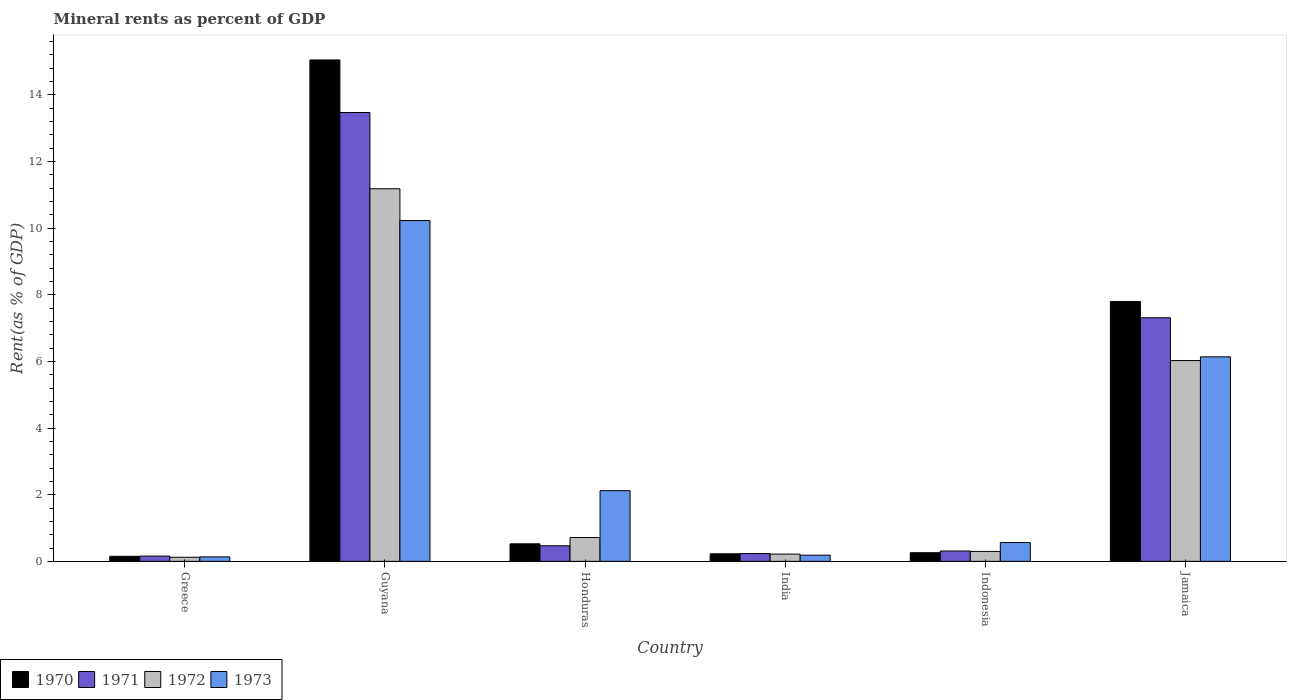How many different coloured bars are there?
Give a very brief answer. 4. How many groups of bars are there?
Keep it short and to the point. 6. How many bars are there on the 4th tick from the right?
Keep it short and to the point. 4. In how many cases, is the number of bars for a given country not equal to the number of legend labels?
Offer a very short reply. 0. What is the mineral rent in 1970 in Greece?
Provide a short and direct response. 0.15. Across all countries, what is the maximum mineral rent in 1972?
Your response must be concise. 11.18. Across all countries, what is the minimum mineral rent in 1972?
Your answer should be compact. 0.12. In which country was the mineral rent in 1971 maximum?
Offer a very short reply. Guyana. In which country was the mineral rent in 1971 minimum?
Give a very brief answer. Greece. What is the total mineral rent in 1972 in the graph?
Ensure brevity in your answer.  18.56. What is the difference between the mineral rent in 1972 in Greece and that in India?
Ensure brevity in your answer.  -0.09. What is the difference between the mineral rent in 1971 in Honduras and the mineral rent in 1970 in Indonesia?
Your response must be concise. 0.21. What is the average mineral rent in 1972 per country?
Give a very brief answer. 3.09. What is the difference between the mineral rent of/in 1973 and mineral rent of/in 1972 in Guyana?
Keep it short and to the point. -0.95. What is the ratio of the mineral rent in 1971 in Greece to that in Guyana?
Your response must be concise. 0.01. Is the mineral rent in 1970 in Greece less than that in India?
Provide a short and direct response. Yes. What is the difference between the highest and the second highest mineral rent in 1972?
Ensure brevity in your answer.  -10.47. What is the difference between the highest and the lowest mineral rent in 1973?
Your answer should be compact. 10.09. In how many countries, is the mineral rent in 1971 greater than the average mineral rent in 1971 taken over all countries?
Offer a very short reply. 2. Is it the case that in every country, the sum of the mineral rent in 1970 and mineral rent in 1973 is greater than the sum of mineral rent in 1972 and mineral rent in 1971?
Ensure brevity in your answer.  No. What does the 3rd bar from the right in India represents?
Keep it short and to the point. 1971. How many bars are there?
Offer a terse response. 24. Are all the bars in the graph horizontal?
Make the answer very short. No. Where does the legend appear in the graph?
Offer a terse response. Bottom left. How many legend labels are there?
Provide a short and direct response. 4. How are the legend labels stacked?
Offer a terse response. Horizontal. What is the title of the graph?
Ensure brevity in your answer.  Mineral rents as percent of GDP. Does "1969" appear as one of the legend labels in the graph?
Give a very brief answer. No. What is the label or title of the Y-axis?
Offer a terse response. Rent(as % of GDP). What is the Rent(as % of GDP) in 1970 in Greece?
Give a very brief answer. 0.15. What is the Rent(as % of GDP) in 1971 in Greece?
Provide a short and direct response. 0.16. What is the Rent(as % of GDP) in 1972 in Greece?
Your response must be concise. 0.12. What is the Rent(as % of GDP) in 1973 in Greece?
Offer a very short reply. 0.13. What is the Rent(as % of GDP) of 1970 in Guyana?
Provide a succinct answer. 15.05. What is the Rent(as % of GDP) in 1971 in Guyana?
Ensure brevity in your answer.  13.47. What is the Rent(as % of GDP) of 1972 in Guyana?
Make the answer very short. 11.18. What is the Rent(as % of GDP) of 1973 in Guyana?
Keep it short and to the point. 10.23. What is the Rent(as % of GDP) in 1970 in Honduras?
Give a very brief answer. 0.53. What is the Rent(as % of GDP) of 1971 in Honduras?
Your answer should be very brief. 0.47. What is the Rent(as % of GDP) of 1972 in Honduras?
Provide a succinct answer. 0.72. What is the Rent(as % of GDP) in 1973 in Honduras?
Keep it short and to the point. 2.12. What is the Rent(as % of GDP) of 1970 in India?
Ensure brevity in your answer.  0.23. What is the Rent(as % of GDP) of 1971 in India?
Your answer should be compact. 0.23. What is the Rent(as % of GDP) in 1972 in India?
Offer a very short reply. 0.22. What is the Rent(as % of GDP) of 1973 in India?
Provide a short and direct response. 0.19. What is the Rent(as % of GDP) in 1970 in Indonesia?
Provide a succinct answer. 0.26. What is the Rent(as % of GDP) in 1971 in Indonesia?
Make the answer very short. 0.31. What is the Rent(as % of GDP) in 1972 in Indonesia?
Provide a succinct answer. 0.3. What is the Rent(as % of GDP) of 1973 in Indonesia?
Provide a short and direct response. 0.56. What is the Rent(as % of GDP) in 1970 in Jamaica?
Provide a short and direct response. 7.8. What is the Rent(as % of GDP) in 1971 in Jamaica?
Your answer should be compact. 7.31. What is the Rent(as % of GDP) in 1972 in Jamaica?
Provide a succinct answer. 6.03. What is the Rent(as % of GDP) in 1973 in Jamaica?
Keep it short and to the point. 6.14. Across all countries, what is the maximum Rent(as % of GDP) in 1970?
Keep it short and to the point. 15.05. Across all countries, what is the maximum Rent(as % of GDP) in 1971?
Provide a short and direct response. 13.47. Across all countries, what is the maximum Rent(as % of GDP) of 1972?
Give a very brief answer. 11.18. Across all countries, what is the maximum Rent(as % of GDP) of 1973?
Provide a succinct answer. 10.23. Across all countries, what is the minimum Rent(as % of GDP) of 1970?
Provide a succinct answer. 0.15. Across all countries, what is the minimum Rent(as % of GDP) in 1971?
Keep it short and to the point. 0.16. Across all countries, what is the minimum Rent(as % of GDP) of 1972?
Your response must be concise. 0.12. Across all countries, what is the minimum Rent(as % of GDP) in 1973?
Keep it short and to the point. 0.13. What is the total Rent(as % of GDP) in 1970 in the graph?
Your response must be concise. 24.01. What is the total Rent(as % of GDP) of 1971 in the graph?
Your response must be concise. 21.95. What is the total Rent(as % of GDP) in 1972 in the graph?
Your response must be concise. 18.56. What is the total Rent(as % of GDP) in 1973 in the graph?
Make the answer very short. 19.37. What is the difference between the Rent(as % of GDP) of 1970 in Greece and that in Guyana?
Your response must be concise. -14.9. What is the difference between the Rent(as % of GDP) of 1971 in Greece and that in Guyana?
Your answer should be compact. -13.31. What is the difference between the Rent(as % of GDP) of 1972 in Greece and that in Guyana?
Offer a very short reply. -11.06. What is the difference between the Rent(as % of GDP) in 1973 in Greece and that in Guyana?
Provide a succinct answer. -10.09. What is the difference between the Rent(as % of GDP) in 1970 in Greece and that in Honduras?
Your answer should be very brief. -0.37. What is the difference between the Rent(as % of GDP) of 1971 in Greece and that in Honduras?
Give a very brief answer. -0.31. What is the difference between the Rent(as % of GDP) of 1972 in Greece and that in Honduras?
Your answer should be compact. -0.59. What is the difference between the Rent(as % of GDP) in 1973 in Greece and that in Honduras?
Offer a very short reply. -1.99. What is the difference between the Rent(as % of GDP) in 1970 in Greece and that in India?
Offer a very short reply. -0.07. What is the difference between the Rent(as % of GDP) of 1971 in Greece and that in India?
Offer a very short reply. -0.08. What is the difference between the Rent(as % of GDP) of 1972 in Greece and that in India?
Your response must be concise. -0.09. What is the difference between the Rent(as % of GDP) of 1973 in Greece and that in India?
Your answer should be very brief. -0.05. What is the difference between the Rent(as % of GDP) of 1970 in Greece and that in Indonesia?
Ensure brevity in your answer.  -0.11. What is the difference between the Rent(as % of GDP) of 1971 in Greece and that in Indonesia?
Keep it short and to the point. -0.15. What is the difference between the Rent(as % of GDP) in 1972 in Greece and that in Indonesia?
Your answer should be compact. -0.18. What is the difference between the Rent(as % of GDP) in 1973 in Greece and that in Indonesia?
Ensure brevity in your answer.  -0.43. What is the difference between the Rent(as % of GDP) in 1970 in Greece and that in Jamaica?
Make the answer very short. -7.65. What is the difference between the Rent(as % of GDP) of 1971 in Greece and that in Jamaica?
Your response must be concise. -7.15. What is the difference between the Rent(as % of GDP) in 1972 in Greece and that in Jamaica?
Your answer should be compact. -5.9. What is the difference between the Rent(as % of GDP) in 1973 in Greece and that in Jamaica?
Your response must be concise. -6. What is the difference between the Rent(as % of GDP) of 1970 in Guyana and that in Honduras?
Offer a very short reply. 14.52. What is the difference between the Rent(as % of GDP) in 1971 in Guyana and that in Honduras?
Your response must be concise. 13. What is the difference between the Rent(as % of GDP) of 1972 in Guyana and that in Honduras?
Offer a very short reply. 10.47. What is the difference between the Rent(as % of GDP) in 1973 in Guyana and that in Honduras?
Give a very brief answer. 8.11. What is the difference between the Rent(as % of GDP) of 1970 in Guyana and that in India?
Your response must be concise. 14.82. What is the difference between the Rent(as % of GDP) in 1971 in Guyana and that in India?
Offer a very short reply. 13.24. What is the difference between the Rent(as % of GDP) in 1972 in Guyana and that in India?
Give a very brief answer. 10.96. What is the difference between the Rent(as % of GDP) in 1973 in Guyana and that in India?
Offer a very short reply. 10.04. What is the difference between the Rent(as % of GDP) of 1970 in Guyana and that in Indonesia?
Ensure brevity in your answer.  14.79. What is the difference between the Rent(as % of GDP) in 1971 in Guyana and that in Indonesia?
Ensure brevity in your answer.  13.16. What is the difference between the Rent(as % of GDP) in 1972 in Guyana and that in Indonesia?
Your answer should be very brief. 10.88. What is the difference between the Rent(as % of GDP) in 1973 in Guyana and that in Indonesia?
Make the answer very short. 9.66. What is the difference between the Rent(as % of GDP) of 1970 in Guyana and that in Jamaica?
Your response must be concise. 7.25. What is the difference between the Rent(as % of GDP) of 1971 in Guyana and that in Jamaica?
Your answer should be very brief. 6.16. What is the difference between the Rent(as % of GDP) of 1972 in Guyana and that in Jamaica?
Your response must be concise. 5.16. What is the difference between the Rent(as % of GDP) of 1973 in Guyana and that in Jamaica?
Your answer should be compact. 4.09. What is the difference between the Rent(as % of GDP) of 1970 in Honduras and that in India?
Provide a succinct answer. 0.3. What is the difference between the Rent(as % of GDP) of 1971 in Honduras and that in India?
Ensure brevity in your answer.  0.23. What is the difference between the Rent(as % of GDP) of 1972 in Honduras and that in India?
Your response must be concise. 0.5. What is the difference between the Rent(as % of GDP) of 1973 in Honduras and that in India?
Provide a succinct answer. 1.94. What is the difference between the Rent(as % of GDP) in 1970 in Honduras and that in Indonesia?
Provide a short and direct response. 0.27. What is the difference between the Rent(as % of GDP) in 1971 in Honduras and that in Indonesia?
Provide a short and direct response. 0.16. What is the difference between the Rent(as % of GDP) of 1972 in Honduras and that in Indonesia?
Your response must be concise. 0.42. What is the difference between the Rent(as % of GDP) in 1973 in Honduras and that in Indonesia?
Keep it short and to the point. 1.56. What is the difference between the Rent(as % of GDP) of 1970 in Honduras and that in Jamaica?
Ensure brevity in your answer.  -7.27. What is the difference between the Rent(as % of GDP) of 1971 in Honduras and that in Jamaica?
Make the answer very short. -6.84. What is the difference between the Rent(as % of GDP) of 1972 in Honduras and that in Jamaica?
Your answer should be very brief. -5.31. What is the difference between the Rent(as % of GDP) in 1973 in Honduras and that in Jamaica?
Your answer should be very brief. -4.02. What is the difference between the Rent(as % of GDP) of 1970 in India and that in Indonesia?
Provide a short and direct response. -0.03. What is the difference between the Rent(as % of GDP) in 1971 in India and that in Indonesia?
Your answer should be compact. -0.08. What is the difference between the Rent(as % of GDP) in 1972 in India and that in Indonesia?
Your response must be concise. -0.08. What is the difference between the Rent(as % of GDP) of 1973 in India and that in Indonesia?
Offer a terse response. -0.38. What is the difference between the Rent(as % of GDP) of 1970 in India and that in Jamaica?
Keep it short and to the point. -7.57. What is the difference between the Rent(as % of GDP) of 1971 in India and that in Jamaica?
Your answer should be very brief. -7.08. What is the difference between the Rent(as % of GDP) in 1972 in India and that in Jamaica?
Provide a succinct answer. -5.81. What is the difference between the Rent(as % of GDP) of 1973 in India and that in Jamaica?
Your answer should be very brief. -5.95. What is the difference between the Rent(as % of GDP) of 1970 in Indonesia and that in Jamaica?
Keep it short and to the point. -7.54. What is the difference between the Rent(as % of GDP) of 1971 in Indonesia and that in Jamaica?
Your response must be concise. -7. What is the difference between the Rent(as % of GDP) of 1972 in Indonesia and that in Jamaica?
Provide a succinct answer. -5.73. What is the difference between the Rent(as % of GDP) in 1973 in Indonesia and that in Jamaica?
Ensure brevity in your answer.  -5.57. What is the difference between the Rent(as % of GDP) in 1970 in Greece and the Rent(as % of GDP) in 1971 in Guyana?
Give a very brief answer. -13.32. What is the difference between the Rent(as % of GDP) of 1970 in Greece and the Rent(as % of GDP) of 1972 in Guyana?
Provide a succinct answer. -11.03. What is the difference between the Rent(as % of GDP) of 1970 in Greece and the Rent(as % of GDP) of 1973 in Guyana?
Ensure brevity in your answer.  -10.08. What is the difference between the Rent(as % of GDP) in 1971 in Greece and the Rent(as % of GDP) in 1972 in Guyana?
Make the answer very short. -11.02. What is the difference between the Rent(as % of GDP) of 1971 in Greece and the Rent(as % of GDP) of 1973 in Guyana?
Your response must be concise. -10.07. What is the difference between the Rent(as % of GDP) in 1972 in Greece and the Rent(as % of GDP) in 1973 in Guyana?
Offer a terse response. -10.1. What is the difference between the Rent(as % of GDP) of 1970 in Greece and the Rent(as % of GDP) of 1971 in Honduras?
Your response must be concise. -0.32. What is the difference between the Rent(as % of GDP) of 1970 in Greece and the Rent(as % of GDP) of 1972 in Honduras?
Your answer should be very brief. -0.56. What is the difference between the Rent(as % of GDP) in 1970 in Greece and the Rent(as % of GDP) in 1973 in Honduras?
Offer a very short reply. -1.97. What is the difference between the Rent(as % of GDP) in 1971 in Greece and the Rent(as % of GDP) in 1972 in Honduras?
Offer a very short reply. -0.56. What is the difference between the Rent(as % of GDP) in 1971 in Greece and the Rent(as % of GDP) in 1973 in Honduras?
Provide a succinct answer. -1.96. What is the difference between the Rent(as % of GDP) in 1972 in Greece and the Rent(as % of GDP) in 1973 in Honduras?
Your response must be concise. -2. What is the difference between the Rent(as % of GDP) of 1970 in Greece and the Rent(as % of GDP) of 1971 in India?
Your response must be concise. -0.08. What is the difference between the Rent(as % of GDP) in 1970 in Greece and the Rent(as % of GDP) in 1972 in India?
Keep it short and to the point. -0.07. What is the difference between the Rent(as % of GDP) of 1970 in Greece and the Rent(as % of GDP) of 1973 in India?
Your response must be concise. -0.03. What is the difference between the Rent(as % of GDP) in 1971 in Greece and the Rent(as % of GDP) in 1972 in India?
Provide a succinct answer. -0.06. What is the difference between the Rent(as % of GDP) of 1971 in Greece and the Rent(as % of GDP) of 1973 in India?
Keep it short and to the point. -0.03. What is the difference between the Rent(as % of GDP) in 1972 in Greece and the Rent(as % of GDP) in 1973 in India?
Offer a very short reply. -0.06. What is the difference between the Rent(as % of GDP) of 1970 in Greece and the Rent(as % of GDP) of 1971 in Indonesia?
Offer a very short reply. -0.16. What is the difference between the Rent(as % of GDP) of 1970 in Greece and the Rent(as % of GDP) of 1972 in Indonesia?
Your answer should be compact. -0.15. What is the difference between the Rent(as % of GDP) in 1970 in Greece and the Rent(as % of GDP) in 1973 in Indonesia?
Provide a short and direct response. -0.41. What is the difference between the Rent(as % of GDP) in 1971 in Greece and the Rent(as % of GDP) in 1972 in Indonesia?
Provide a short and direct response. -0.14. What is the difference between the Rent(as % of GDP) of 1971 in Greece and the Rent(as % of GDP) of 1973 in Indonesia?
Ensure brevity in your answer.  -0.41. What is the difference between the Rent(as % of GDP) in 1972 in Greece and the Rent(as % of GDP) in 1973 in Indonesia?
Your answer should be very brief. -0.44. What is the difference between the Rent(as % of GDP) of 1970 in Greece and the Rent(as % of GDP) of 1971 in Jamaica?
Provide a short and direct response. -7.16. What is the difference between the Rent(as % of GDP) in 1970 in Greece and the Rent(as % of GDP) in 1972 in Jamaica?
Make the answer very short. -5.87. What is the difference between the Rent(as % of GDP) in 1970 in Greece and the Rent(as % of GDP) in 1973 in Jamaica?
Give a very brief answer. -5.99. What is the difference between the Rent(as % of GDP) in 1971 in Greece and the Rent(as % of GDP) in 1972 in Jamaica?
Provide a short and direct response. -5.87. What is the difference between the Rent(as % of GDP) of 1971 in Greece and the Rent(as % of GDP) of 1973 in Jamaica?
Make the answer very short. -5.98. What is the difference between the Rent(as % of GDP) in 1972 in Greece and the Rent(as % of GDP) in 1973 in Jamaica?
Make the answer very short. -6.01. What is the difference between the Rent(as % of GDP) of 1970 in Guyana and the Rent(as % of GDP) of 1971 in Honduras?
Offer a terse response. 14.58. What is the difference between the Rent(as % of GDP) in 1970 in Guyana and the Rent(as % of GDP) in 1972 in Honduras?
Make the answer very short. 14.33. What is the difference between the Rent(as % of GDP) in 1970 in Guyana and the Rent(as % of GDP) in 1973 in Honduras?
Offer a very short reply. 12.93. What is the difference between the Rent(as % of GDP) in 1971 in Guyana and the Rent(as % of GDP) in 1972 in Honduras?
Provide a short and direct response. 12.75. What is the difference between the Rent(as % of GDP) of 1971 in Guyana and the Rent(as % of GDP) of 1973 in Honduras?
Your answer should be very brief. 11.35. What is the difference between the Rent(as % of GDP) of 1972 in Guyana and the Rent(as % of GDP) of 1973 in Honduras?
Provide a succinct answer. 9.06. What is the difference between the Rent(as % of GDP) of 1970 in Guyana and the Rent(as % of GDP) of 1971 in India?
Give a very brief answer. 14.81. What is the difference between the Rent(as % of GDP) in 1970 in Guyana and the Rent(as % of GDP) in 1972 in India?
Ensure brevity in your answer.  14.83. What is the difference between the Rent(as % of GDP) of 1970 in Guyana and the Rent(as % of GDP) of 1973 in India?
Keep it short and to the point. 14.86. What is the difference between the Rent(as % of GDP) in 1971 in Guyana and the Rent(as % of GDP) in 1972 in India?
Provide a succinct answer. 13.25. What is the difference between the Rent(as % of GDP) of 1971 in Guyana and the Rent(as % of GDP) of 1973 in India?
Provide a short and direct response. 13.28. What is the difference between the Rent(as % of GDP) of 1972 in Guyana and the Rent(as % of GDP) of 1973 in India?
Offer a terse response. 11. What is the difference between the Rent(as % of GDP) in 1970 in Guyana and the Rent(as % of GDP) in 1971 in Indonesia?
Ensure brevity in your answer.  14.74. What is the difference between the Rent(as % of GDP) of 1970 in Guyana and the Rent(as % of GDP) of 1972 in Indonesia?
Keep it short and to the point. 14.75. What is the difference between the Rent(as % of GDP) in 1970 in Guyana and the Rent(as % of GDP) in 1973 in Indonesia?
Keep it short and to the point. 14.48. What is the difference between the Rent(as % of GDP) in 1971 in Guyana and the Rent(as % of GDP) in 1972 in Indonesia?
Your answer should be very brief. 13.17. What is the difference between the Rent(as % of GDP) in 1971 in Guyana and the Rent(as % of GDP) in 1973 in Indonesia?
Offer a terse response. 12.91. What is the difference between the Rent(as % of GDP) in 1972 in Guyana and the Rent(as % of GDP) in 1973 in Indonesia?
Provide a succinct answer. 10.62. What is the difference between the Rent(as % of GDP) of 1970 in Guyana and the Rent(as % of GDP) of 1971 in Jamaica?
Keep it short and to the point. 7.74. What is the difference between the Rent(as % of GDP) in 1970 in Guyana and the Rent(as % of GDP) in 1972 in Jamaica?
Give a very brief answer. 9.02. What is the difference between the Rent(as % of GDP) of 1970 in Guyana and the Rent(as % of GDP) of 1973 in Jamaica?
Ensure brevity in your answer.  8.91. What is the difference between the Rent(as % of GDP) of 1971 in Guyana and the Rent(as % of GDP) of 1972 in Jamaica?
Your answer should be compact. 7.44. What is the difference between the Rent(as % of GDP) of 1971 in Guyana and the Rent(as % of GDP) of 1973 in Jamaica?
Offer a very short reply. 7.33. What is the difference between the Rent(as % of GDP) of 1972 in Guyana and the Rent(as % of GDP) of 1973 in Jamaica?
Make the answer very short. 5.04. What is the difference between the Rent(as % of GDP) in 1970 in Honduras and the Rent(as % of GDP) in 1971 in India?
Your answer should be compact. 0.29. What is the difference between the Rent(as % of GDP) of 1970 in Honduras and the Rent(as % of GDP) of 1972 in India?
Your answer should be compact. 0.31. What is the difference between the Rent(as % of GDP) in 1970 in Honduras and the Rent(as % of GDP) in 1973 in India?
Provide a short and direct response. 0.34. What is the difference between the Rent(as % of GDP) in 1971 in Honduras and the Rent(as % of GDP) in 1972 in India?
Your answer should be compact. 0.25. What is the difference between the Rent(as % of GDP) in 1971 in Honduras and the Rent(as % of GDP) in 1973 in India?
Give a very brief answer. 0.28. What is the difference between the Rent(as % of GDP) of 1972 in Honduras and the Rent(as % of GDP) of 1973 in India?
Provide a short and direct response. 0.53. What is the difference between the Rent(as % of GDP) of 1970 in Honduras and the Rent(as % of GDP) of 1971 in Indonesia?
Ensure brevity in your answer.  0.22. What is the difference between the Rent(as % of GDP) of 1970 in Honduras and the Rent(as % of GDP) of 1972 in Indonesia?
Your answer should be compact. 0.23. What is the difference between the Rent(as % of GDP) of 1970 in Honduras and the Rent(as % of GDP) of 1973 in Indonesia?
Keep it short and to the point. -0.04. What is the difference between the Rent(as % of GDP) of 1971 in Honduras and the Rent(as % of GDP) of 1972 in Indonesia?
Your answer should be very brief. 0.17. What is the difference between the Rent(as % of GDP) of 1971 in Honduras and the Rent(as % of GDP) of 1973 in Indonesia?
Ensure brevity in your answer.  -0.1. What is the difference between the Rent(as % of GDP) of 1972 in Honduras and the Rent(as % of GDP) of 1973 in Indonesia?
Your response must be concise. 0.15. What is the difference between the Rent(as % of GDP) of 1970 in Honduras and the Rent(as % of GDP) of 1971 in Jamaica?
Provide a short and direct response. -6.78. What is the difference between the Rent(as % of GDP) of 1970 in Honduras and the Rent(as % of GDP) of 1972 in Jamaica?
Ensure brevity in your answer.  -5.5. What is the difference between the Rent(as % of GDP) in 1970 in Honduras and the Rent(as % of GDP) in 1973 in Jamaica?
Your answer should be very brief. -5.61. What is the difference between the Rent(as % of GDP) of 1971 in Honduras and the Rent(as % of GDP) of 1972 in Jamaica?
Provide a short and direct response. -5.56. What is the difference between the Rent(as % of GDP) of 1971 in Honduras and the Rent(as % of GDP) of 1973 in Jamaica?
Your answer should be compact. -5.67. What is the difference between the Rent(as % of GDP) in 1972 in Honduras and the Rent(as % of GDP) in 1973 in Jamaica?
Offer a very short reply. -5.42. What is the difference between the Rent(as % of GDP) in 1970 in India and the Rent(as % of GDP) in 1971 in Indonesia?
Keep it short and to the point. -0.08. What is the difference between the Rent(as % of GDP) of 1970 in India and the Rent(as % of GDP) of 1972 in Indonesia?
Provide a short and direct response. -0.07. What is the difference between the Rent(as % of GDP) of 1970 in India and the Rent(as % of GDP) of 1973 in Indonesia?
Offer a very short reply. -0.34. What is the difference between the Rent(as % of GDP) in 1971 in India and the Rent(as % of GDP) in 1972 in Indonesia?
Provide a short and direct response. -0.07. What is the difference between the Rent(as % of GDP) in 1971 in India and the Rent(as % of GDP) in 1973 in Indonesia?
Provide a succinct answer. -0.33. What is the difference between the Rent(as % of GDP) of 1972 in India and the Rent(as % of GDP) of 1973 in Indonesia?
Make the answer very short. -0.35. What is the difference between the Rent(as % of GDP) of 1970 in India and the Rent(as % of GDP) of 1971 in Jamaica?
Make the answer very short. -7.08. What is the difference between the Rent(as % of GDP) of 1970 in India and the Rent(as % of GDP) of 1972 in Jamaica?
Ensure brevity in your answer.  -5.8. What is the difference between the Rent(as % of GDP) of 1970 in India and the Rent(as % of GDP) of 1973 in Jamaica?
Offer a terse response. -5.91. What is the difference between the Rent(as % of GDP) in 1971 in India and the Rent(as % of GDP) in 1972 in Jamaica?
Give a very brief answer. -5.79. What is the difference between the Rent(as % of GDP) of 1971 in India and the Rent(as % of GDP) of 1973 in Jamaica?
Make the answer very short. -5.9. What is the difference between the Rent(as % of GDP) of 1972 in India and the Rent(as % of GDP) of 1973 in Jamaica?
Your response must be concise. -5.92. What is the difference between the Rent(as % of GDP) of 1970 in Indonesia and the Rent(as % of GDP) of 1971 in Jamaica?
Your answer should be very brief. -7.05. What is the difference between the Rent(as % of GDP) in 1970 in Indonesia and the Rent(as % of GDP) in 1972 in Jamaica?
Your response must be concise. -5.77. What is the difference between the Rent(as % of GDP) in 1970 in Indonesia and the Rent(as % of GDP) in 1973 in Jamaica?
Offer a terse response. -5.88. What is the difference between the Rent(as % of GDP) in 1971 in Indonesia and the Rent(as % of GDP) in 1972 in Jamaica?
Your response must be concise. -5.72. What is the difference between the Rent(as % of GDP) of 1971 in Indonesia and the Rent(as % of GDP) of 1973 in Jamaica?
Provide a succinct answer. -5.83. What is the difference between the Rent(as % of GDP) in 1972 in Indonesia and the Rent(as % of GDP) in 1973 in Jamaica?
Your response must be concise. -5.84. What is the average Rent(as % of GDP) in 1970 per country?
Ensure brevity in your answer.  4. What is the average Rent(as % of GDP) in 1971 per country?
Your answer should be compact. 3.66. What is the average Rent(as % of GDP) of 1972 per country?
Offer a very short reply. 3.09. What is the average Rent(as % of GDP) of 1973 per country?
Keep it short and to the point. 3.23. What is the difference between the Rent(as % of GDP) in 1970 and Rent(as % of GDP) in 1971 in Greece?
Your answer should be compact. -0.01. What is the difference between the Rent(as % of GDP) in 1970 and Rent(as % of GDP) in 1972 in Greece?
Your answer should be compact. 0.03. What is the difference between the Rent(as % of GDP) in 1970 and Rent(as % of GDP) in 1973 in Greece?
Make the answer very short. 0.02. What is the difference between the Rent(as % of GDP) in 1971 and Rent(as % of GDP) in 1972 in Greece?
Provide a short and direct response. 0.04. What is the difference between the Rent(as % of GDP) in 1971 and Rent(as % of GDP) in 1973 in Greece?
Provide a short and direct response. 0.02. What is the difference between the Rent(as % of GDP) in 1972 and Rent(as % of GDP) in 1973 in Greece?
Offer a terse response. -0.01. What is the difference between the Rent(as % of GDP) in 1970 and Rent(as % of GDP) in 1971 in Guyana?
Ensure brevity in your answer.  1.58. What is the difference between the Rent(as % of GDP) in 1970 and Rent(as % of GDP) in 1972 in Guyana?
Your answer should be compact. 3.87. What is the difference between the Rent(as % of GDP) in 1970 and Rent(as % of GDP) in 1973 in Guyana?
Keep it short and to the point. 4.82. What is the difference between the Rent(as % of GDP) of 1971 and Rent(as % of GDP) of 1972 in Guyana?
Offer a very short reply. 2.29. What is the difference between the Rent(as % of GDP) of 1971 and Rent(as % of GDP) of 1973 in Guyana?
Offer a very short reply. 3.24. What is the difference between the Rent(as % of GDP) in 1972 and Rent(as % of GDP) in 1973 in Guyana?
Give a very brief answer. 0.95. What is the difference between the Rent(as % of GDP) in 1970 and Rent(as % of GDP) in 1971 in Honduras?
Ensure brevity in your answer.  0.06. What is the difference between the Rent(as % of GDP) in 1970 and Rent(as % of GDP) in 1972 in Honduras?
Offer a very short reply. -0.19. What is the difference between the Rent(as % of GDP) of 1970 and Rent(as % of GDP) of 1973 in Honduras?
Offer a terse response. -1.59. What is the difference between the Rent(as % of GDP) of 1971 and Rent(as % of GDP) of 1972 in Honduras?
Provide a succinct answer. -0.25. What is the difference between the Rent(as % of GDP) of 1971 and Rent(as % of GDP) of 1973 in Honduras?
Offer a terse response. -1.65. What is the difference between the Rent(as % of GDP) in 1972 and Rent(as % of GDP) in 1973 in Honduras?
Keep it short and to the point. -1.41. What is the difference between the Rent(as % of GDP) of 1970 and Rent(as % of GDP) of 1971 in India?
Offer a terse response. -0.01. What is the difference between the Rent(as % of GDP) of 1970 and Rent(as % of GDP) of 1972 in India?
Offer a very short reply. 0.01. What is the difference between the Rent(as % of GDP) in 1970 and Rent(as % of GDP) in 1973 in India?
Give a very brief answer. 0.04. What is the difference between the Rent(as % of GDP) in 1971 and Rent(as % of GDP) in 1972 in India?
Keep it short and to the point. 0.02. What is the difference between the Rent(as % of GDP) in 1971 and Rent(as % of GDP) in 1973 in India?
Your answer should be very brief. 0.05. What is the difference between the Rent(as % of GDP) of 1972 and Rent(as % of GDP) of 1973 in India?
Your answer should be compact. 0.03. What is the difference between the Rent(as % of GDP) in 1970 and Rent(as % of GDP) in 1971 in Indonesia?
Offer a terse response. -0.05. What is the difference between the Rent(as % of GDP) of 1970 and Rent(as % of GDP) of 1972 in Indonesia?
Your answer should be very brief. -0.04. What is the difference between the Rent(as % of GDP) in 1970 and Rent(as % of GDP) in 1973 in Indonesia?
Your answer should be very brief. -0.3. What is the difference between the Rent(as % of GDP) in 1971 and Rent(as % of GDP) in 1972 in Indonesia?
Your answer should be compact. 0.01. What is the difference between the Rent(as % of GDP) of 1971 and Rent(as % of GDP) of 1973 in Indonesia?
Your response must be concise. -0.25. What is the difference between the Rent(as % of GDP) of 1972 and Rent(as % of GDP) of 1973 in Indonesia?
Ensure brevity in your answer.  -0.27. What is the difference between the Rent(as % of GDP) of 1970 and Rent(as % of GDP) of 1971 in Jamaica?
Provide a succinct answer. 0.49. What is the difference between the Rent(as % of GDP) in 1970 and Rent(as % of GDP) in 1972 in Jamaica?
Provide a short and direct response. 1.77. What is the difference between the Rent(as % of GDP) of 1970 and Rent(as % of GDP) of 1973 in Jamaica?
Your answer should be compact. 1.66. What is the difference between the Rent(as % of GDP) of 1971 and Rent(as % of GDP) of 1972 in Jamaica?
Keep it short and to the point. 1.28. What is the difference between the Rent(as % of GDP) of 1971 and Rent(as % of GDP) of 1973 in Jamaica?
Your answer should be very brief. 1.17. What is the difference between the Rent(as % of GDP) in 1972 and Rent(as % of GDP) in 1973 in Jamaica?
Give a very brief answer. -0.11. What is the ratio of the Rent(as % of GDP) in 1970 in Greece to that in Guyana?
Offer a terse response. 0.01. What is the ratio of the Rent(as % of GDP) in 1971 in Greece to that in Guyana?
Keep it short and to the point. 0.01. What is the ratio of the Rent(as % of GDP) of 1972 in Greece to that in Guyana?
Your answer should be very brief. 0.01. What is the ratio of the Rent(as % of GDP) of 1973 in Greece to that in Guyana?
Your answer should be very brief. 0.01. What is the ratio of the Rent(as % of GDP) of 1970 in Greece to that in Honduras?
Give a very brief answer. 0.29. What is the ratio of the Rent(as % of GDP) in 1971 in Greece to that in Honduras?
Offer a terse response. 0.34. What is the ratio of the Rent(as % of GDP) in 1972 in Greece to that in Honduras?
Give a very brief answer. 0.17. What is the ratio of the Rent(as % of GDP) in 1973 in Greece to that in Honduras?
Ensure brevity in your answer.  0.06. What is the ratio of the Rent(as % of GDP) of 1970 in Greece to that in India?
Offer a very short reply. 0.67. What is the ratio of the Rent(as % of GDP) of 1971 in Greece to that in India?
Your response must be concise. 0.68. What is the ratio of the Rent(as % of GDP) of 1972 in Greece to that in India?
Offer a very short reply. 0.57. What is the ratio of the Rent(as % of GDP) of 1973 in Greece to that in India?
Offer a terse response. 0.73. What is the ratio of the Rent(as % of GDP) of 1970 in Greece to that in Indonesia?
Give a very brief answer. 0.58. What is the ratio of the Rent(as % of GDP) in 1971 in Greece to that in Indonesia?
Your answer should be compact. 0.51. What is the ratio of the Rent(as % of GDP) in 1972 in Greece to that in Indonesia?
Offer a very short reply. 0.41. What is the ratio of the Rent(as % of GDP) of 1973 in Greece to that in Indonesia?
Your response must be concise. 0.24. What is the ratio of the Rent(as % of GDP) in 1970 in Greece to that in Jamaica?
Provide a short and direct response. 0.02. What is the ratio of the Rent(as % of GDP) of 1971 in Greece to that in Jamaica?
Your response must be concise. 0.02. What is the ratio of the Rent(as % of GDP) of 1972 in Greece to that in Jamaica?
Your answer should be very brief. 0.02. What is the ratio of the Rent(as % of GDP) of 1973 in Greece to that in Jamaica?
Offer a terse response. 0.02. What is the ratio of the Rent(as % of GDP) of 1970 in Guyana to that in Honduras?
Offer a very short reply. 28.59. What is the ratio of the Rent(as % of GDP) of 1971 in Guyana to that in Honduras?
Provide a succinct answer. 28.82. What is the ratio of the Rent(as % of GDP) in 1972 in Guyana to that in Honduras?
Offer a terse response. 15.63. What is the ratio of the Rent(as % of GDP) in 1973 in Guyana to that in Honduras?
Give a very brief answer. 4.82. What is the ratio of the Rent(as % of GDP) of 1970 in Guyana to that in India?
Your response must be concise. 66.33. What is the ratio of the Rent(as % of GDP) of 1971 in Guyana to that in India?
Your answer should be compact. 57.65. What is the ratio of the Rent(as % of GDP) in 1972 in Guyana to that in India?
Your answer should be very brief. 51.44. What is the ratio of the Rent(as % of GDP) of 1973 in Guyana to that in India?
Offer a very short reply. 55. What is the ratio of the Rent(as % of GDP) of 1970 in Guyana to that in Indonesia?
Ensure brevity in your answer.  57.85. What is the ratio of the Rent(as % of GDP) of 1971 in Guyana to that in Indonesia?
Keep it short and to the point. 43.38. What is the ratio of the Rent(as % of GDP) of 1972 in Guyana to that in Indonesia?
Provide a short and direct response. 37.44. What is the ratio of the Rent(as % of GDP) of 1973 in Guyana to that in Indonesia?
Ensure brevity in your answer.  18.12. What is the ratio of the Rent(as % of GDP) in 1970 in Guyana to that in Jamaica?
Your answer should be very brief. 1.93. What is the ratio of the Rent(as % of GDP) of 1971 in Guyana to that in Jamaica?
Provide a succinct answer. 1.84. What is the ratio of the Rent(as % of GDP) of 1972 in Guyana to that in Jamaica?
Give a very brief answer. 1.86. What is the ratio of the Rent(as % of GDP) of 1973 in Guyana to that in Jamaica?
Provide a succinct answer. 1.67. What is the ratio of the Rent(as % of GDP) of 1970 in Honduras to that in India?
Provide a short and direct response. 2.32. What is the ratio of the Rent(as % of GDP) of 1971 in Honduras to that in India?
Offer a terse response. 2. What is the ratio of the Rent(as % of GDP) of 1972 in Honduras to that in India?
Make the answer very short. 3.29. What is the ratio of the Rent(as % of GDP) in 1973 in Honduras to that in India?
Keep it short and to the point. 11.41. What is the ratio of the Rent(as % of GDP) of 1970 in Honduras to that in Indonesia?
Your response must be concise. 2.02. What is the ratio of the Rent(as % of GDP) in 1971 in Honduras to that in Indonesia?
Your response must be concise. 1.51. What is the ratio of the Rent(as % of GDP) in 1972 in Honduras to that in Indonesia?
Make the answer very short. 2.4. What is the ratio of the Rent(as % of GDP) of 1973 in Honduras to that in Indonesia?
Ensure brevity in your answer.  3.76. What is the ratio of the Rent(as % of GDP) in 1970 in Honduras to that in Jamaica?
Offer a terse response. 0.07. What is the ratio of the Rent(as % of GDP) in 1971 in Honduras to that in Jamaica?
Ensure brevity in your answer.  0.06. What is the ratio of the Rent(as % of GDP) of 1972 in Honduras to that in Jamaica?
Give a very brief answer. 0.12. What is the ratio of the Rent(as % of GDP) of 1973 in Honduras to that in Jamaica?
Your answer should be very brief. 0.35. What is the ratio of the Rent(as % of GDP) in 1970 in India to that in Indonesia?
Provide a short and direct response. 0.87. What is the ratio of the Rent(as % of GDP) in 1971 in India to that in Indonesia?
Your answer should be compact. 0.75. What is the ratio of the Rent(as % of GDP) of 1972 in India to that in Indonesia?
Provide a succinct answer. 0.73. What is the ratio of the Rent(as % of GDP) of 1973 in India to that in Indonesia?
Give a very brief answer. 0.33. What is the ratio of the Rent(as % of GDP) in 1970 in India to that in Jamaica?
Your answer should be very brief. 0.03. What is the ratio of the Rent(as % of GDP) of 1971 in India to that in Jamaica?
Provide a succinct answer. 0.03. What is the ratio of the Rent(as % of GDP) of 1972 in India to that in Jamaica?
Your answer should be very brief. 0.04. What is the ratio of the Rent(as % of GDP) of 1973 in India to that in Jamaica?
Offer a terse response. 0.03. What is the ratio of the Rent(as % of GDP) in 1970 in Indonesia to that in Jamaica?
Provide a succinct answer. 0.03. What is the ratio of the Rent(as % of GDP) in 1971 in Indonesia to that in Jamaica?
Your response must be concise. 0.04. What is the ratio of the Rent(as % of GDP) of 1972 in Indonesia to that in Jamaica?
Make the answer very short. 0.05. What is the ratio of the Rent(as % of GDP) in 1973 in Indonesia to that in Jamaica?
Your response must be concise. 0.09. What is the difference between the highest and the second highest Rent(as % of GDP) of 1970?
Your answer should be compact. 7.25. What is the difference between the highest and the second highest Rent(as % of GDP) in 1971?
Make the answer very short. 6.16. What is the difference between the highest and the second highest Rent(as % of GDP) of 1972?
Ensure brevity in your answer.  5.16. What is the difference between the highest and the second highest Rent(as % of GDP) in 1973?
Ensure brevity in your answer.  4.09. What is the difference between the highest and the lowest Rent(as % of GDP) of 1970?
Provide a succinct answer. 14.9. What is the difference between the highest and the lowest Rent(as % of GDP) in 1971?
Give a very brief answer. 13.31. What is the difference between the highest and the lowest Rent(as % of GDP) of 1972?
Ensure brevity in your answer.  11.06. What is the difference between the highest and the lowest Rent(as % of GDP) in 1973?
Keep it short and to the point. 10.09. 